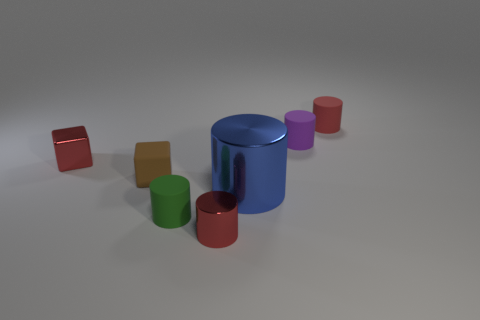What is the color of the metal object that is the same size as the red metallic cube?
Offer a terse response. Red. What number of objects are either red things that are in front of the tiny purple rubber cylinder or tiny red cylinders?
Your answer should be compact. 3. How many other objects are there of the same size as the purple rubber thing?
Make the answer very short. 5. What is the size of the red cylinder that is to the left of the purple cylinder?
Keep it short and to the point. Small. What is the shape of the green thing that is the same material as the small brown cube?
Your answer should be compact. Cylinder. Are there any other things that have the same color as the metallic cube?
Keep it short and to the point. Yes. There is a small metallic thing that is to the left of the red cylinder that is in front of the small purple thing; what color is it?
Offer a terse response. Red. What number of small things are either red shiny objects or red shiny cylinders?
Your response must be concise. 2. There is a purple thing that is the same shape as the green matte thing; what is its material?
Offer a terse response. Rubber. Are there any other things that are made of the same material as the purple object?
Offer a very short reply. Yes. 